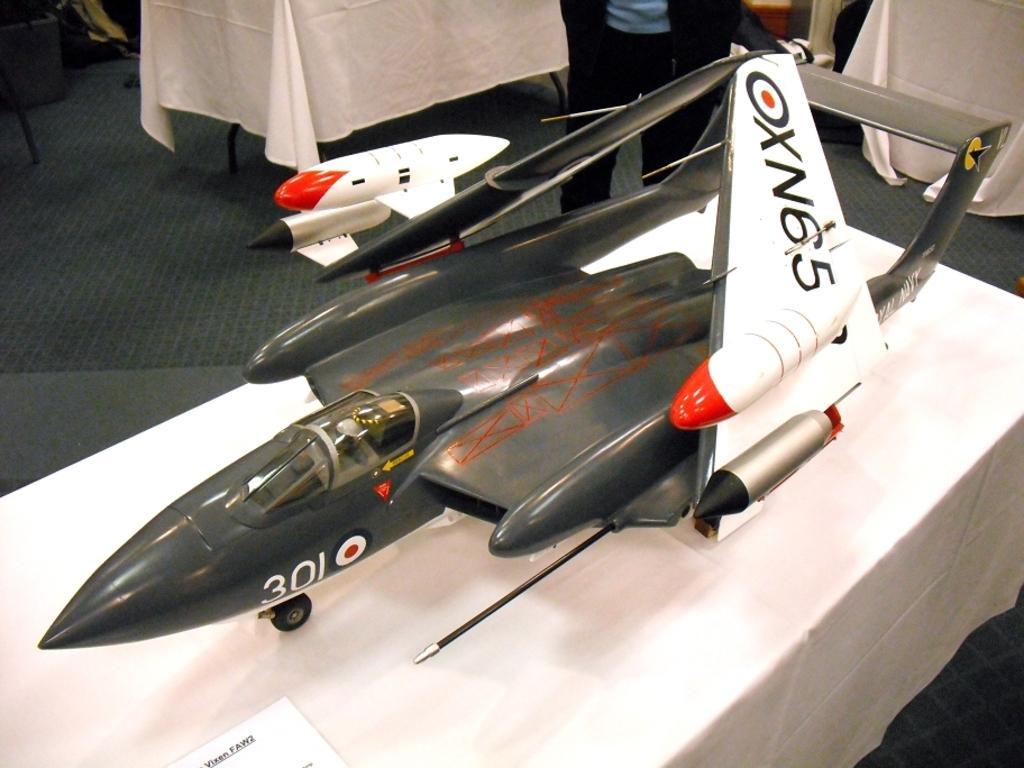Could you give a brief overview of what you see in this image? In this image there is a toy aeroplane in the front which is on the table with some text written on it which is in white and black in colour. In the background there is a person standing and there are tables covered with a white colour cloth and there is an aeroplane which is white and red in colour and there is an empty chair. 